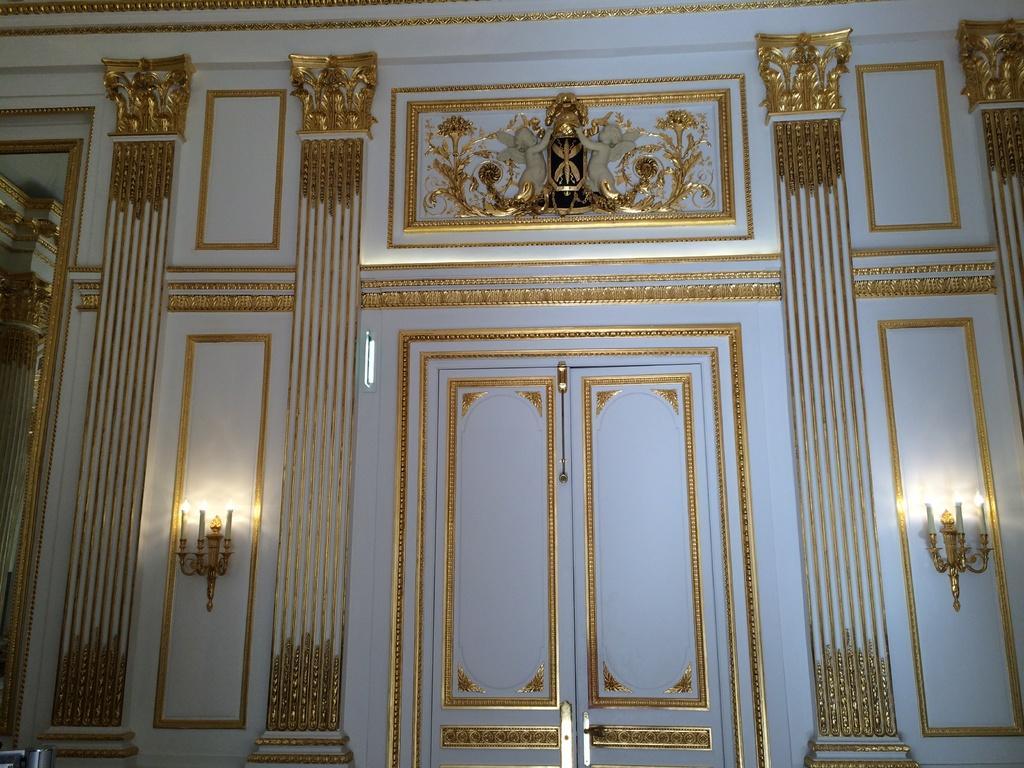Describe this image in one or two sentences. In this image I can see two doors in the centre and on the both sides of it I can see six candles. On the top side of this image I can see few sculptures. 